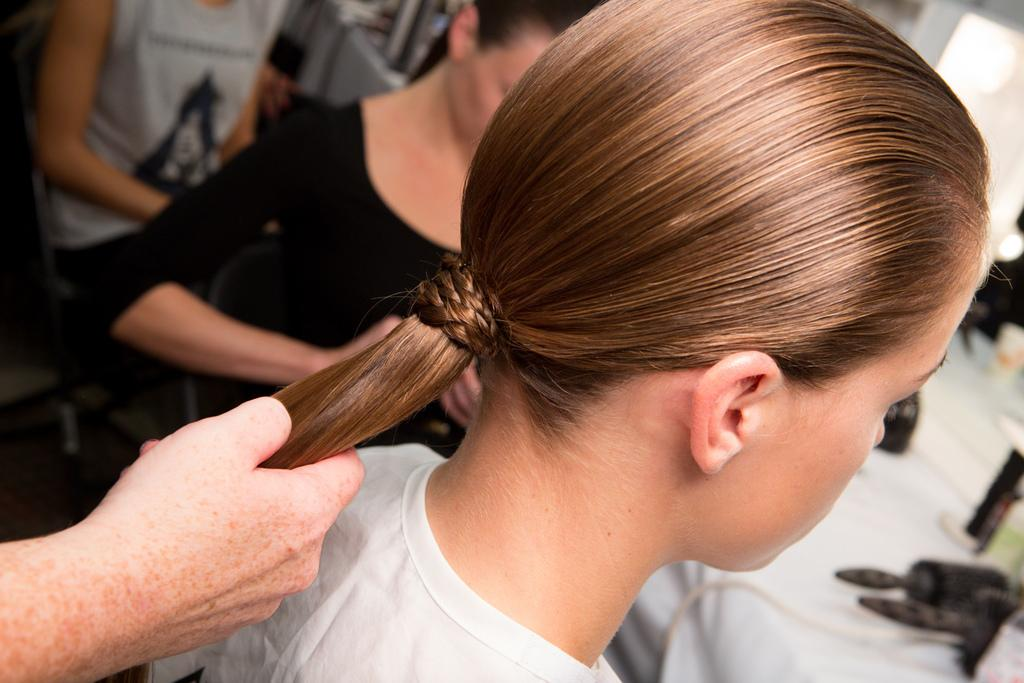How many people are in the image? There is a group of people standing in the image. Can you describe one of the individuals in the group? One person is wearing a white shirt and has long hair. What can be seen in the background of the image? In the background, there is a group of brushes and bottles placed on a table. What type of furniture is being used by the person wearing the white shirt? There is no furniture mentioned or visible in the image. How many plates are on the table with the bottles? There is no table with plates mentioned or visible in the image. 